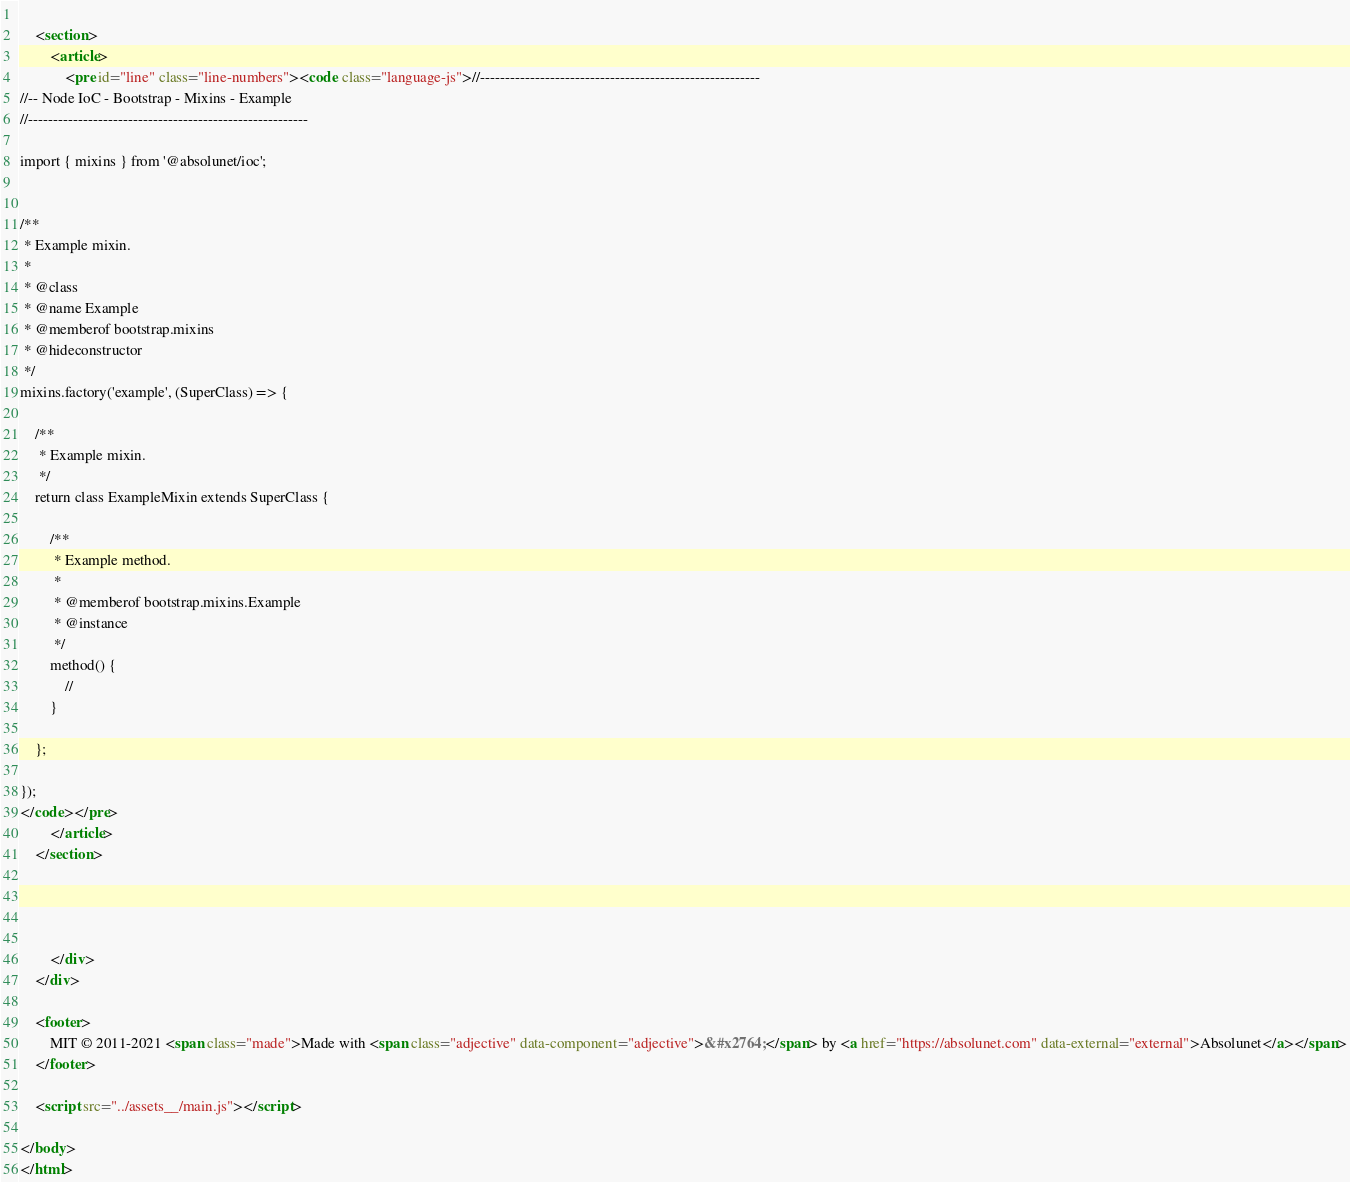<code> <loc_0><loc_0><loc_500><loc_500><_HTML_>
    
    <section>
        <article>
            <pre id="line" class="line-numbers"><code class="language-js">//--------------------------------------------------------
//-- Node IoC - Bootstrap - Mixins - Example
//--------------------------------------------------------

import { mixins } from '@absolunet/ioc';


/**
 * Example mixin.
 *
 * @class
 * @name Example
 * @memberof bootstrap.mixins
 * @hideconstructor
 */
mixins.factory('example', (SuperClass) => {

	/**
	 * Example mixin.
	 */
	return class ExampleMixin extends SuperClass {

		/**
		 * Example method.
		 *
		 * @memberof bootstrap.mixins.Example
		 * @instance
		 */
		method() {
			//
		}

	};

});
</code></pre>
        </article>
    </section>




		</div>
	</div>

	<footer>
		MIT © 2011-2021 <span class="made">Made with <span class="adjective" data-component="adjective">&#x2764;</span> by <a href="https://absolunet.com" data-external="external">Absolunet</a></span>
	</footer>

	<script src="../assets__/main.js"></script>

</body>
</html>
</code> 